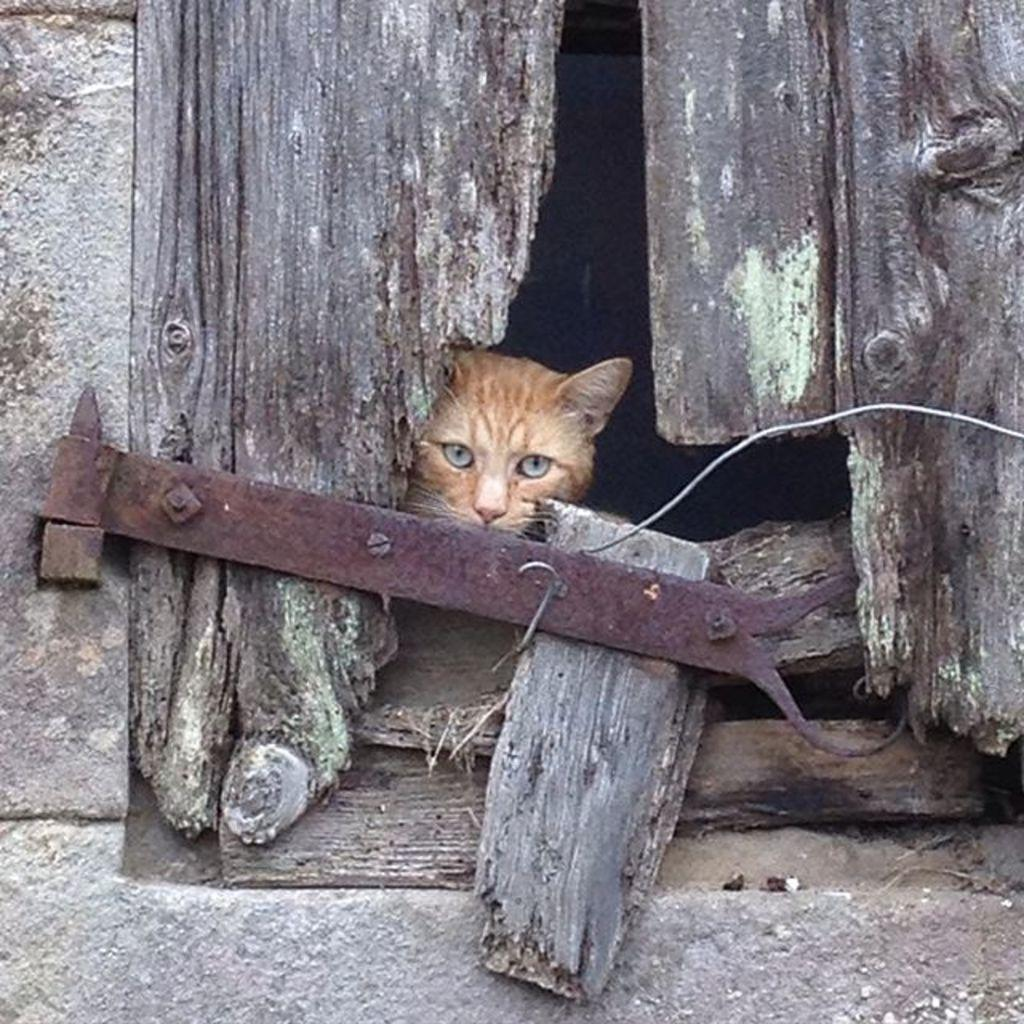What type of structure is shown in the image? There is a wall of a building in the image. What feature can be seen on the wall? The wall has a wooden window. What is unique about the wooden window? The wooden window has a hole. What can be seen through the hole in the window? There is a cat visible through the hole. How would you describe the overall color scheme of the image? The background of the image is dark in color. What type of bird can be seen perched on the cat's head in the image? There is no bird visible in the image, let alone one perched on the cat's head. 